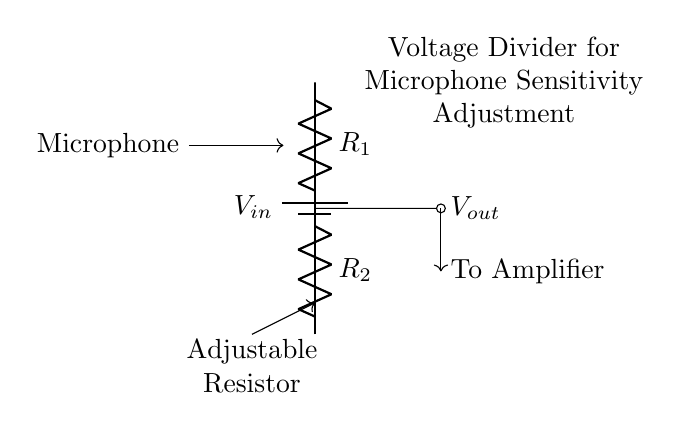What is the input voltage in this circuit? The input voltage is denoted as \(V_{in}\) in the circuit diagram, which represents the voltage supplied to the circuit.
Answer: Vin What component is used to control microphone sensitivity? The adjustable resistor labeled in the circuit enables fine-tuning of the microphone sensitivity by changing the resistance and, consequently, the output voltage.
Answer: Adjustable Resistor What is the role of \(R_1\) and \(R_2\) in this circuit? \(R_1\) and \(R_2\) form the voltage divider, which divides the input voltage to produce a reduced output voltage (\(V_{out}\)) that is sent to the amplifier.
Answer: Voltage Divider What does \(V_{out}\) represent in this circuit? \(V_{out}\) is the output voltage that results from the division of the input voltage by the resistors \(R_1\) and \(R_2\), which in this case is used for the subsequent amplification of the microphone signal.
Answer: Vout How is the output voltage affected if \(R_1\) is increased? Increasing \(R_1\) relative to \(R_2\) will increase the output voltage (\(V_{out}\)), based on the voltage divider formula, which states that more resistance at the top increases the voltage at the output.
Answer: Increases Where does the output from the voltage divider go? The output from the voltage divider, represented as \(V_{out}\), is directed to the amplifier for further processing of the microphone signal in the sound system.
Answer: To Amplifier 